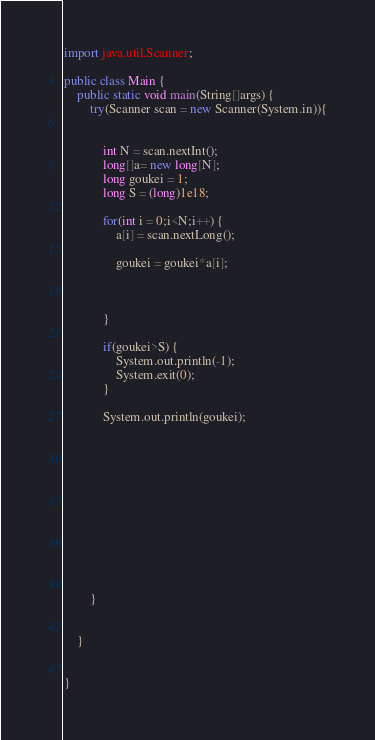<code> <loc_0><loc_0><loc_500><loc_500><_Java_>import java.util.Scanner;

public class Main {
	public static void main(String[]args) {
		try(Scanner scan = new Scanner(System.in)){
			
			
			int N = scan.nextInt();
			long[]a= new long[N];
			long goukei = 1;
			long S = (long)1e18;
			
			for(int i = 0;i<N;i++) {
				a[i] = scan.nextLong();
				
				goukei = goukei*a[i];
				
				
			
			}
			
			if(goukei>S) {
				System.out.println(-1);
				System.exit(0);
			}
			
			System.out.println(goukei);
			
			
			
			
			
			
			
			
			
			
			
			
		}
		
		
	}
		

}
</code> 